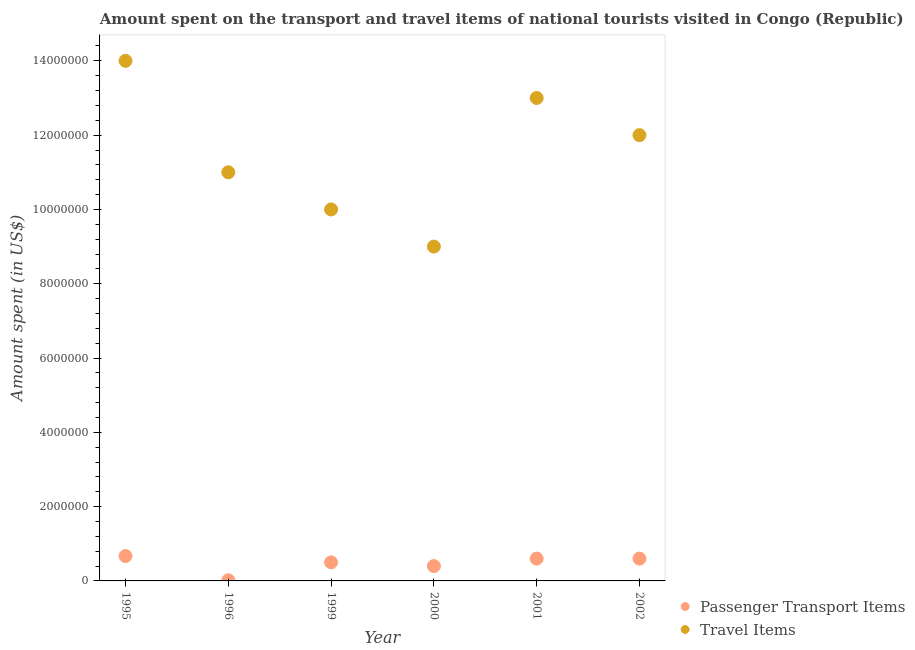How many different coloured dotlines are there?
Provide a succinct answer. 2. Is the number of dotlines equal to the number of legend labels?
Give a very brief answer. Yes. What is the amount spent on passenger transport items in 1996?
Make the answer very short. 1.76e+04. Across all years, what is the maximum amount spent on passenger transport items?
Your answer should be very brief. 6.69e+05. Across all years, what is the minimum amount spent in travel items?
Your answer should be compact. 9.00e+06. In which year was the amount spent in travel items minimum?
Make the answer very short. 2000. What is the total amount spent in travel items in the graph?
Provide a short and direct response. 6.90e+07. What is the difference between the amount spent on passenger transport items in 2000 and that in 2002?
Your answer should be very brief. -2.00e+05. What is the difference between the amount spent in travel items in 2001 and the amount spent on passenger transport items in 2002?
Keep it short and to the point. 1.24e+07. What is the average amount spent on passenger transport items per year?
Keep it short and to the point. 4.64e+05. In the year 1996, what is the difference between the amount spent in travel items and amount spent on passenger transport items?
Your answer should be compact. 1.10e+07. What is the ratio of the amount spent in travel items in 1995 to that in 2000?
Your response must be concise. 1.56. Is the amount spent on passenger transport items in 1996 less than that in 2002?
Give a very brief answer. Yes. Is the difference between the amount spent on passenger transport items in 1995 and 2001 greater than the difference between the amount spent in travel items in 1995 and 2001?
Ensure brevity in your answer.  No. What is the difference between the highest and the second highest amount spent in travel items?
Make the answer very short. 1.00e+06. What is the difference between the highest and the lowest amount spent in travel items?
Your answer should be very brief. 5.00e+06. In how many years, is the amount spent on passenger transport items greater than the average amount spent on passenger transport items taken over all years?
Offer a terse response. 4. Is the amount spent on passenger transport items strictly greater than the amount spent in travel items over the years?
Your response must be concise. No. How many years are there in the graph?
Provide a short and direct response. 6. Are the values on the major ticks of Y-axis written in scientific E-notation?
Offer a very short reply. No. Does the graph contain grids?
Ensure brevity in your answer.  No. How many legend labels are there?
Offer a very short reply. 2. How are the legend labels stacked?
Give a very brief answer. Vertical. What is the title of the graph?
Provide a succinct answer. Amount spent on the transport and travel items of national tourists visited in Congo (Republic). What is the label or title of the X-axis?
Provide a short and direct response. Year. What is the label or title of the Y-axis?
Offer a very short reply. Amount spent (in US$). What is the Amount spent (in US$) of Passenger Transport Items in 1995?
Ensure brevity in your answer.  6.69e+05. What is the Amount spent (in US$) in Travel Items in 1995?
Offer a terse response. 1.40e+07. What is the Amount spent (in US$) of Passenger Transport Items in 1996?
Make the answer very short. 1.76e+04. What is the Amount spent (in US$) in Travel Items in 1996?
Keep it short and to the point. 1.10e+07. What is the Amount spent (in US$) in Passenger Transport Items in 1999?
Keep it short and to the point. 5.00e+05. What is the Amount spent (in US$) of Travel Items in 2000?
Make the answer very short. 9.00e+06. What is the Amount spent (in US$) in Travel Items in 2001?
Provide a succinct answer. 1.30e+07. Across all years, what is the maximum Amount spent (in US$) of Passenger Transport Items?
Offer a terse response. 6.69e+05. Across all years, what is the maximum Amount spent (in US$) in Travel Items?
Keep it short and to the point. 1.40e+07. Across all years, what is the minimum Amount spent (in US$) in Passenger Transport Items?
Make the answer very short. 1.76e+04. Across all years, what is the minimum Amount spent (in US$) of Travel Items?
Make the answer very short. 9.00e+06. What is the total Amount spent (in US$) of Passenger Transport Items in the graph?
Ensure brevity in your answer.  2.79e+06. What is the total Amount spent (in US$) in Travel Items in the graph?
Keep it short and to the point. 6.90e+07. What is the difference between the Amount spent (in US$) in Passenger Transport Items in 1995 and that in 1996?
Ensure brevity in your answer.  6.52e+05. What is the difference between the Amount spent (in US$) of Travel Items in 1995 and that in 1996?
Ensure brevity in your answer.  3.00e+06. What is the difference between the Amount spent (in US$) of Passenger Transport Items in 1995 and that in 1999?
Your response must be concise. 1.69e+05. What is the difference between the Amount spent (in US$) of Passenger Transport Items in 1995 and that in 2000?
Offer a terse response. 2.69e+05. What is the difference between the Amount spent (in US$) in Passenger Transport Items in 1995 and that in 2001?
Provide a short and direct response. 6.91e+04. What is the difference between the Amount spent (in US$) of Travel Items in 1995 and that in 2001?
Offer a terse response. 1.00e+06. What is the difference between the Amount spent (in US$) in Passenger Transport Items in 1995 and that in 2002?
Provide a succinct answer. 6.91e+04. What is the difference between the Amount spent (in US$) of Passenger Transport Items in 1996 and that in 1999?
Provide a succinct answer. -4.82e+05. What is the difference between the Amount spent (in US$) in Travel Items in 1996 and that in 1999?
Your answer should be compact. 1.00e+06. What is the difference between the Amount spent (in US$) in Passenger Transport Items in 1996 and that in 2000?
Offer a terse response. -3.82e+05. What is the difference between the Amount spent (in US$) in Travel Items in 1996 and that in 2000?
Offer a terse response. 2.00e+06. What is the difference between the Amount spent (in US$) in Passenger Transport Items in 1996 and that in 2001?
Offer a terse response. -5.82e+05. What is the difference between the Amount spent (in US$) in Passenger Transport Items in 1996 and that in 2002?
Offer a very short reply. -5.82e+05. What is the difference between the Amount spent (in US$) in Travel Items in 1999 and that in 2000?
Your answer should be compact. 1.00e+06. What is the difference between the Amount spent (in US$) of Passenger Transport Items in 1999 and that in 2001?
Make the answer very short. -1.00e+05. What is the difference between the Amount spent (in US$) in Travel Items in 1999 and that in 2001?
Make the answer very short. -3.00e+06. What is the difference between the Amount spent (in US$) of Passenger Transport Items in 1999 and that in 2002?
Your response must be concise. -1.00e+05. What is the difference between the Amount spent (in US$) in Travel Items in 2000 and that in 2001?
Keep it short and to the point. -4.00e+06. What is the difference between the Amount spent (in US$) of Passenger Transport Items in 2000 and that in 2002?
Your answer should be very brief. -2.00e+05. What is the difference between the Amount spent (in US$) in Travel Items in 2000 and that in 2002?
Your answer should be compact. -3.00e+06. What is the difference between the Amount spent (in US$) in Passenger Transport Items in 2001 and that in 2002?
Give a very brief answer. 0. What is the difference between the Amount spent (in US$) in Travel Items in 2001 and that in 2002?
Your answer should be very brief. 1.00e+06. What is the difference between the Amount spent (in US$) of Passenger Transport Items in 1995 and the Amount spent (in US$) of Travel Items in 1996?
Make the answer very short. -1.03e+07. What is the difference between the Amount spent (in US$) in Passenger Transport Items in 1995 and the Amount spent (in US$) in Travel Items in 1999?
Your answer should be compact. -9.33e+06. What is the difference between the Amount spent (in US$) of Passenger Transport Items in 1995 and the Amount spent (in US$) of Travel Items in 2000?
Your answer should be compact. -8.33e+06. What is the difference between the Amount spent (in US$) in Passenger Transport Items in 1995 and the Amount spent (in US$) in Travel Items in 2001?
Keep it short and to the point. -1.23e+07. What is the difference between the Amount spent (in US$) in Passenger Transport Items in 1995 and the Amount spent (in US$) in Travel Items in 2002?
Your answer should be very brief. -1.13e+07. What is the difference between the Amount spent (in US$) in Passenger Transport Items in 1996 and the Amount spent (in US$) in Travel Items in 1999?
Make the answer very short. -9.98e+06. What is the difference between the Amount spent (in US$) in Passenger Transport Items in 1996 and the Amount spent (in US$) in Travel Items in 2000?
Ensure brevity in your answer.  -8.98e+06. What is the difference between the Amount spent (in US$) in Passenger Transport Items in 1996 and the Amount spent (in US$) in Travel Items in 2001?
Provide a succinct answer. -1.30e+07. What is the difference between the Amount spent (in US$) in Passenger Transport Items in 1996 and the Amount spent (in US$) in Travel Items in 2002?
Give a very brief answer. -1.20e+07. What is the difference between the Amount spent (in US$) of Passenger Transport Items in 1999 and the Amount spent (in US$) of Travel Items in 2000?
Your answer should be compact. -8.50e+06. What is the difference between the Amount spent (in US$) of Passenger Transport Items in 1999 and the Amount spent (in US$) of Travel Items in 2001?
Keep it short and to the point. -1.25e+07. What is the difference between the Amount spent (in US$) of Passenger Transport Items in 1999 and the Amount spent (in US$) of Travel Items in 2002?
Offer a terse response. -1.15e+07. What is the difference between the Amount spent (in US$) of Passenger Transport Items in 2000 and the Amount spent (in US$) of Travel Items in 2001?
Offer a very short reply. -1.26e+07. What is the difference between the Amount spent (in US$) in Passenger Transport Items in 2000 and the Amount spent (in US$) in Travel Items in 2002?
Provide a succinct answer. -1.16e+07. What is the difference between the Amount spent (in US$) in Passenger Transport Items in 2001 and the Amount spent (in US$) in Travel Items in 2002?
Offer a very short reply. -1.14e+07. What is the average Amount spent (in US$) of Passenger Transport Items per year?
Your answer should be very brief. 4.64e+05. What is the average Amount spent (in US$) in Travel Items per year?
Make the answer very short. 1.15e+07. In the year 1995, what is the difference between the Amount spent (in US$) in Passenger Transport Items and Amount spent (in US$) in Travel Items?
Make the answer very short. -1.33e+07. In the year 1996, what is the difference between the Amount spent (in US$) of Passenger Transport Items and Amount spent (in US$) of Travel Items?
Offer a very short reply. -1.10e+07. In the year 1999, what is the difference between the Amount spent (in US$) in Passenger Transport Items and Amount spent (in US$) in Travel Items?
Provide a short and direct response. -9.50e+06. In the year 2000, what is the difference between the Amount spent (in US$) in Passenger Transport Items and Amount spent (in US$) in Travel Items?
Ensure brevity in your answer.  -8.60e+06. In the year 2001, what is the difference between the Amount spent (in US$) of Passenger Transport Items and Amount spent (in US$) of Travel Items?
Offer a very short reply. -1.24e+07. In the year 2002, what is the difference between the Amount spent (in US$) of Passenger Transport Items and Amount spent (in US$) of Travel Items?
Give a very brief answer. -1.14e+07. What is the ratio of the Amount spent (in US$) of Passenger Transport Items in 1995 to that in 1996?
Offer a very short reply. 38.03. What is the ratio of the Amount spent (in US$) in Travel Items in 1995 to that in 1996?
Make the answer very short. 1.27. What is the ratio of the Amount spent (in US$) of Passenger Transport Items in 1995 to that in 1999?
Provide a succinct answer. 1.34. What is the ratio of the Amount spent (in US$) of Passenger Transport Items in 1995 to that in 2000?
Offer a terse response. 1.67. What is the ratio of the Amount spent (in US$) of Travel Items in 1995 to that in 2000?
Your response must be concise. 1.56. What is the ratio of the Amount spent (in US$) of Passenger Transport Items in 1995 to that in 2001?
Offer a terse response. 1.12. What is the ratio of the Amount spent (in US$) in Travel Items in 1995 to that in 2001?
Your answer should be compact. 1.08. What is the ratio of the Amount spent (in US$) of Passenger Transport Items in 1995 to that in 2002?
Your answer should be compact. 1.12. What is the ratio of the Amount spent (in US$) in Travel Items in 1995 to that in 2002?
Ensure brevity in your answer.  1.17. What is the ratio of the Amount spent (in US$) of Passenger Transport Items in 1996 to that in 1999?
Offer a very short reply. 0.04. What is the ratio of the Amount spent (in US$) of Passenger Transport Items in 1996 to that in 2000?
Make the answer very short. 0.04. What is the ratio of the Amount spent (in US$) of Travel Items in 1996 to that in 2000?
Your answer should be compact. 1.22. What is the ratio of the Amount spent (in US$) of Passenger Transport Items in 1996 to that in 2001?
Give a very brief answer. 0.03. What is the ratio of the Amount spent (in US$) of Travel Items in 1996 to that in 2001?
Your response must be concise. 0.85. What is the ratio of the Amount spent (in US$) in Passenger Transport Items in 1996 to that in 2002?
Ensure brevity in your answer.  0.03. What is the ratio of the Amount spent (in US$) of Passenger Transport Items in 1999 to that in 2000?
Provide a succinct answer. 1.25. What is the ratio of the Amount spent (in US$) in Passenger Transport Items in 1999 to that in 2001?
Keep it short and to the point. 0.83. What is the ratio of the Amount spent (in US$) of Travel Items in 1999 to that in 2001?
Offer a very short reply. 0.77. What is the ratio of the Amount spent (in US$) of Passenger Transport Items in 1999 to that in 2002?
Make the answer very short. 0.83. What is the ratio of the Amount spent (in US$) in Travel Items in 1999 to that in 2002?
Provide a succinct answer. 0.83. What is the ratio of the Amount spent (in US$) of Passenger Transport Items in 2000 to that in 2001?
Keep it short and to the point. 0.67. What is the ratio of the Amount spent (in US$) of Travel Items in 2000 to that in 2001?
Your answer should be very brief. 0.69. What is the ratio of the Amount spent (in US$) of Travel Items in 2000 to that in 2002?
Offer a very short reply. 0.75. What is the ratio of the Amount spent (in US$) of Travel Items in 2001 to that in 2002?
Your response must be concise. 1.08. What is the difference between the highest and the second highest Amount spent (in US$) in Passenger Transport Items?
Your answer should be very brief. 6.91e+04. What is the difference between the highest and the second highest Amount spent (in US$) of Travel Items?
Provide a succinct answer. 1.00e+06. What is the difference between the highest and the lowest Amount spent (in US$) of Passenger Transport Items?
Your response must be concise. 6.52e+05. 